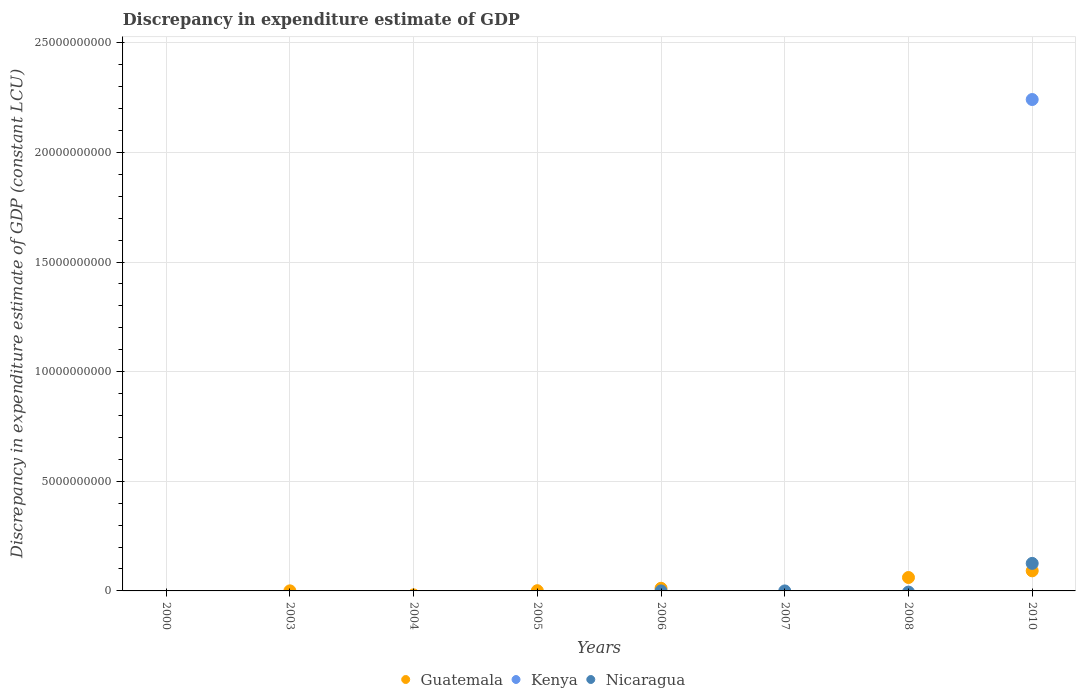How many different coloured dotlines are there?
Ensure brevity in your answer.  3. Is the number of dotlines equal to the number of legend labels?
Your answer should be compact. No. What is the discrepancy in expenditure estimate of GDP in Nicaragua in 2010?
Your response must be concise. 1.26e+09. Across all years, what is the maximum discrepancy in expenditure estimate of GDP in Kenya?
Provide a short and direct response. 2.24e+1. What is the total discrepancy in expenditure estimate of GDP in Kenya in the graph?
Offer a terse response. 2.24e+1. What is the difference between the discrepancy in expenditure estimate of GDP in Guatemala in 2003 and the discrepancy in expenditure estimate of GDP in Nicaragua in 2008?
Provide a succinct answer. 3.20e+06. What is the average discrepancy in expenditure estimate of GDP in Kenya per year?
Make the answer very short. 2.80e+09. In the year 2010, what is the difference between the discrepancy in expenditure estimate of GDP in Nicaragua and discrepancy in expenditure estimate of GDP in Guatemala?
Provide a short and direct response. 3.39e+08. What is the ratio of the discrepancy in expenditure estimate of GDP in Guatemala in 2003 to that in 2005?
Ensure brevity in your answer.  0.32. What is the difference between the highest and the second highest discrepancy in expenditure estimate of GDP in Guatemala?
Your answer should be compact. 3.04e+08. What is the difference between the highest and the lowest discrepancy in expenditure estimate of GDP in Guatemala?
Offer a terse response. 9.16e+08. In how many years, is the discrepancy in expenditure estimate of GDP in Nicaragua greater than the average discrepancy in expenditure estimate of GDP in Nicaragua taken over all years?
Your response must be concise. 1. Is it the case that in every year, the sum of the discrepancy in expenditure estimate of GDP in Kenya and discrepancy in expenditure estimate of GDP in Nicaragua  is greater than the discrepancy in expenditure estimate of GDP in Guatemala?
Ensure brevity in your answer.  No. What is the difference between two consecutive major ticks on the Y-axis?
Offer a very short reply. 5.00e+09. Does the graph contain grids?
Provide a succinct answer. Yes. What is the title of the graph?
Your response must be concise. Discrepancy in expenditure estimate of GDP. Does "Lao PDR" appear as one of the legend labels in the graph?
Your response must be concise. No. What is the label or title of the Y-axis?
Provide a succinct answer. Discrepancy in expenditure estimate of GDP (constant LCU). What is the Discrepancy in expenditure estimate of GDP (constant LCU) of Guatemala in 2000?
Your response must be concise. 0. What is the Discrepancy in expenditure estimate of GDP (constant LCU) in Nicaragua in 2000?
Give a very brief answer. 0. What is the Discrepancy in expenditure estimate of GDP (constant LCU) in Guatemala in 2003?
Offer a very short reply. 3.20e+06. What is the Discrepancy in expenditure estimate of GDP (constant LCU) in Kenya in 2004?
Give a very brief answer. 0. What is the Discrepancy in expenditure estimate of GDP (constant LCU) of Nicaragua in 2004?
Your answer should be compact. 0. What is the Discrepancy in expenditure estimate of GDP (constant LCU) in Kenya in 2005?
Make the answer very short. 0. What is the Discrepancy in expenditure estimate of GDP (constant LCU) of Guatemala in 2006?
Provide a short and direct response. 1.20e+08. What is the Discrepancy in expenditure estimate of GDP (constant LCU) of Kenya in 2006?
Give a very brief answer. 0. What is the Discrepancy in expenditure estimate of GDP (constant LCU) in Nicaragua in 2007?
Give a very brief answer. 0. What is the Discrepancy in expenditure estimate of GDP (constant LCU) of Guatemala in 2008?
Offer a terse response. 6.12e+08. What is the Discrepancy in expenditure estimate of GDP (constant LCU) in Nicaragua in 2008?
Provide a short and direct response. 0. What is the Discrepancy in expenditure estimate of GDP (constant LCU) of Guatemala in 2010?
Your answer should be compact. 9.16e+08. What is the Discrepancy in expenditure estimate of GDP (constant LCU) in Kenya in 2010?
Provide a short and direct response. 2.24e+1. What is the Discrepancy in expenditure estimate of GDP (constant LCU) in Nicaragua in 2010?
Make the answer very short. 1.26e+09. Across all years, what is the maximum Discrepancy in expenditure estimate of GDP (constant LCU) in Guatemala?
Offer a terse response. 9.16e+08. Across all years, what is the maximum Discrepancy in expenditure estimate of GDP (constant LCU) in Kenya?
Your response must be concise. 2.24e+1. Across all years, what is the maximum Discrepancy in expenditure estimate of GDP (constant LCU) in Nicaragua?
Keep it short and to the point. 1.26e+09. What is the total Discrepancy in expenditure estimate of GDP (constant LCU) of Guatemala in the graph?
Your answer should be compact. 1.66e+09. What is the total Discrepancy in expenditure estimate of GDP (constant LCU) in Kenya in the graph?
Give a very brief answer. 2.24e+1. What is the total Discrepancy in expenditure estimate of GDP (constant LCU) in Nicaragua in the graph?
Your answer should be compact. 1.26e+09. What is the difference between the Discrepancy in expenditure estimate of GDP (constant LCU) of Guatemala in 2003 and that in 2005?
Your answer should be compact. -6.80e+06. What is the difference between the Discrepancy in expenditure estimate of GDP (constant LCU) of Guatemala in 2003 and that in 2006?
Your answer should be very brief. -1.17e+08. What is the difference between the Discrepancy in expenditure estimate of GDP (constant LCU) in Guatemala in 2003 and that in 2008?
Make the answer very short. -6.09e+08. What is the difference between the Discrepancy in expenditure estimate of GDP (constant LCU) of Guatemala in 2003 and that in 2010?
Offer a terse response. -9.13e+08. What is the difference between the Discrepancy in expenditure estimate of GDP (constant LCU) of Guatemala in 2005 and that in 2006?
Make the answer very short. -1.10e+08. What is the difference between the Discrepancy in expenditure estimate of GDP (constant LCU) in Guatemala in 2005 and that in 2008?
Offer a very short reply. -6.02e+08. What is the difference between the Discrepancy in expenditure estimate of GDP (constant LCU) in Guatemala in 2005 and that in 2010?
Ensure brevity in your answer.  -9.06e+08. What is the difference between the Discrepancy in expenditure estimate of GDP (constant LCU) of Guatemala in 2006 and that in 2008?
Offer a very short reply. -4.92e+08. What is the difference between the Discrepancy in expenditure estimate of GDP (constant LCU) of Guatemala in 2006 and that in 2010?
Provide a succinct answer. -7.96e+08. What is the difference between the Discrepancy in expenditure estimate of GDP (constant LCU) of Guatemala in 2008 and that in 2010?
Keep it short and to the point. -3.04e+08. What is the difference between the Discrepancy in expenditure estimate of GDP (constant LCU) in Guatemala in 2003 and the Discrepancy in expenditure estimate of GDP (constant LCU) in Kenya in 2010?
Offer a very short reply. -2.24e+1. What is the difference between the Discrepancy in expenditure estimate of GDP (constant LCU) in Guatemala in 2003 and the Discrepancy in expenditure estimate of GDP (constant LCU) in Nicaragua in 2010?
Offer a very short reply. -1.25e+09. What is the difference between the Discrepancy in expenditure estimate of GDP (constant LCU) of Guatemala in 2005 and the Discrepancy in expenditure estimate of GDP (constant LCU) of Kenya in 2010?
Keep it short and to the point. -2.24e+1. What is the difference between the Discrepancy in expenditure estimate of GDP (constant LCU) in Guatemala in 2005 and the Discrepancy in expenditure estimate of GDP (constant LCU) in Nicaragua in 2010?
Give a very brief answer. -1.25e+09. What is the difference between the Discrepancy in expenditure estimate of GDP (constant LCU) of Guatemala in 2006 and the Discrepancy in expenditure estimate of GDP (constant LCU) of Kenya in 2010?
Your response must be concise. -2.23e+1. What is the difference between the Discrepancy in expenditure estimate of GDP (constant LCU) of Guatemala in 2006 and the Discrepancy in expenditure estimate of GDP (constant LCU) of Nicaragua in 2010?
Offer a terse response. -1.14e+09. What is the difference between the Discrepancy in expenditure estimate of GDP (constant LCU) of Guatemala in 2008 and the Discrepancy in expenditure estimate of GDP (constant LCU) of Kenya in 2010?
Provide a succinct answer. -2.18e+1. What is the difference between the Discrepancy in expenditure estimate of GDP (constant LCU) of Guatemala in 2008 and the Discrepancy in expenditure estimate of GDP (constant LCU) of Nicaragua in 2010?
Offer a terse response. -6.43e+08. What is the average Discrepancy in expenditure estimate of GDP (constant LCU) in Guatemala per year?
Provide a short and direct response. 2.08e+08. What is the average Discrepancy in expenditure estimate of GDP (constant LCU) of Kenya per year?
Make the answer very short. 2.80e+09. What is the average Discrepancy in expenditure estimate of GDP (constant LCU) of Nicaragua per year?
Provide a succinct answer. 1.57e+08. In the year 2010, what is the difference between the Discrepancy in expenditure estimate of GDP (constant LCU) of Guatemala and Discrepancy in expenditure estimate of GDP (constant LCU) of Kenya?
Provide a short and direct response. -2.15e+1. In the year 2010, what is the difference between the Discrepancy in expenditure estimate of GDP (constant LCU) in Guatemala and Discrepancy in expenditure estimate of GDP (constant LCU) in Nicaragua?
Your answer should be very brief. -3.39e+08. In the year 2010, what is the difference between the Discrepancy in expenditure estimate of GDP (constant LCU) in Kenya and Discrepancy in expenditure estimate of GDP (constant LCU) in Nicaragua?
Offer a very short reply. 2.12e+1. What is the ratio of the Discrepancy in expenditure estimate of GDP (constant LCU) of Guatemala in 2003 to that in 2005?
Give a very brief answer. 0.32. What is the ratio of the Discrepancy in expenditure estimate of GDP (constant LCU) in Guatemala in 2003 to that in 2006?
Your answer should be compact. 0.03. What is the ratio of the Discrepancy in expenditure estimate of GDP (constant LCU) in Guatemala in 2003 to that in 2008?
Offer a terse response. 0.01. What is the ratio of the Discrepancy in expenditure estimate of GDP (constant LCU) in Guatemala in 2003 to that in 2010?
Your response must be concise. 0. What is the ratio of the Discrepancy in expenditure estimate of GDP (constant LCU) of Guatemala in 2005 to that in 2006?
Ensure brevity in your answer.  0.08. What is the ratio of the Discrepancy in expenditure estimate of GDP (constant LCU) in Guatemala in 2005 to that in 2008?
Provide a succinct answer. 0.02. What is the ratio of the Discrepancy in expenditure estimate of GDP (constant LCU) of Guatemala in 2005 to that in 2010?
Your answer should be compact. 0.01. What is the ratio of the Discrepancy in expenditure estimate of GDP (constant LCU) in Guatemala in 2006 to that in 2008?
Provide a short and direct response. 0.2. What is the ratio of the Discrepancy in expenditure estimate of GDP (constant LCU) of Guatemala in 2006 to that in 2010?
Offer a very short reply. 0.13. What is the ratio of the Discrepancy in expenditure estimate of GDP (constant LCU) of Guatemala in 2008 to that in 2010?
Ensure brevity in your answer.  0.67. What is the difference between the highest and the second highest Discrepancy in expenditure estimate of GDP (constant LCU) in Guatemala?
Provide a succinct answer. 3.04e+08. What is the difference between the highest and the lowest Discrepancy in expenditure estimate of GDP (constant LCU) in Guatemala?
Offer a very short reply. 9.16e+08. What is the difference between the highest and the lowest Discrepancy in expenditure estimate of GDP (constant LCU) of Kenya?
Your response must be concise. 2.24e+1. What is the difference between the highest and the lowest Discrepancy in expenditure estimate of GDP (constant LCU) of Nicaragua?
Your answer should be very brief. 1.26e+09. 